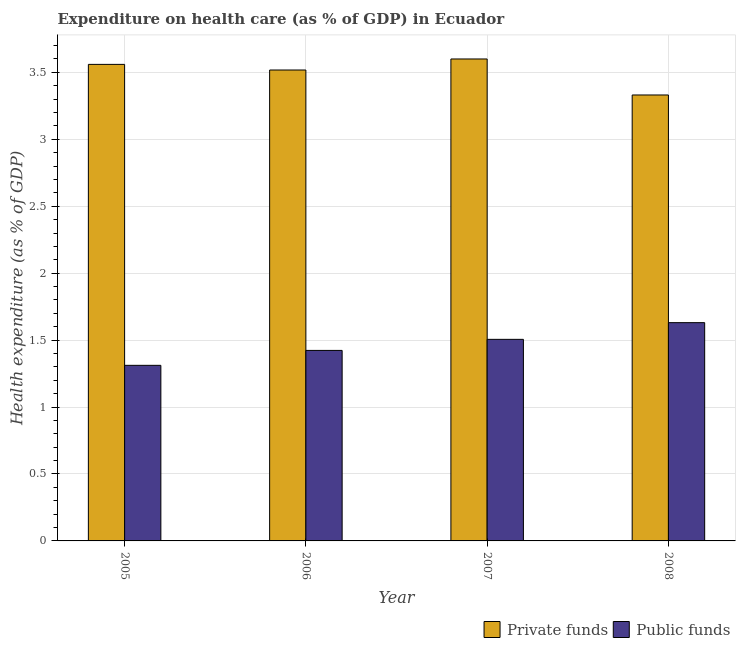How many different coloured bars are there?
Your answer should be compact. 2. How many groups of bars are there?
Keep it short and to the point. 4. Are the number of bars per tick equal to the number of legend labels?
Give a very brief answer. Yes. Are the number of bars on each tick of the X-axis equal?
Offer a very short reply. Yes. What is the label of the 3rd group of bars from the left?
Make the answer very short. 2007. In how many cases, is the number of bars for a given year not equal to the number of legend labels?
Provide a succinct answer. 0. What is the amount of public funds spent in healthcare in 2005?
Keep it short and to the point. 1.31. Across all years, what is the maximum amount of public funds spent in healthcare?
Offer a very short reply. 1.63. Across all years, what is the minimum amount of private funds spent in healthcare?
Give a very brief answer. 3.33. In which year was the amount of private funds spent in healthcare maximum?
Ensure brevity in your answer.  2007. What is the total amount of public funds spent in healthcare in the graph?
Offer a terse response. 5.87. What is the difference between the amount of public funds spent in healthcare in 2006 and that in 2008?
Offer a very short reply. -0.21. What is the difference between the amount of private funds spent in healthcare in 2005 and the amount of public funds spent in healthcare in 2008?
Provide a succinct answer. 0.23. What is the average amount of private funds spent in healthcare per year?
Keep it short and to the point. 3.5. In the year 2006, what is the difference between the amount of private funds spent in healthcare and amount of public funds spent in healthcare?
Make the answer very short. 0. What is the ratio of the amount of private funds spent in healthcare in 2005 to that in 2008?
Your response must be concise. 1.07. Is the amount of public funds spent in healthcare in 2006 less than that in 2007?
Keep it short and to the point. Yes. What is the difference between the highest and the second highest amount of public funds spent in healthcare?
Offer a very short reply. 0.12. What is the difference between the highest and the lowest amount of public funds spent in healthcare?
Your answer should be very brief. 0.32. In how many years, is the amount of public funds spent in healthcare greater than the average amount of public funds spent in healthcare taken over all years?
Provide a succinct answer. 2. What does the 1st bar from the left in 2007 represents?
Keep it short and to the point. Private funds. What does the 1st bar from the right in 2008 represents?
Give a very brief answer. Public funds. How many bars are there?
Offer a terse response. 8. Are all the bars in the graph horizontal?
Make the answer very short. No. Are the values on the major ticks of Y-axis written in scientific E-notation?
Your answer should be very brief. No. Where does the legend appear in the graph?
Your answer should be compact. Bottom right. How are the legend labels stacked?
Your answer should be very brief. Horizontal. What is the title of the graph?
Your answer should be compact. Expenditure on health care (as % of GDP) in Ecuador. What is the label or title of the Y-axis?
Offer a terse response. Health expenditure (as % of GDP). What is the Health expenditure (as % of GDP) in Private funds in 2005?
Offer a very short reply. 3.56. What is the Health expenditure (as % of GDP) of Public funds in 2005?
Keep it short and to the point. 1.31. What is the Health expenditure (as % of GDP) of Private funds in 2006?
Your response must be concise. 3.52. What is the Health expenditure (as % of GDP) in Public funds in 2006?
Make the answer very short. 1.42. What is the Health expenditure (as % of GDP) in Private funds in 2007?
Keep it short and to the point. 3.6. What is the Health expenditure (as % of GDP) of Public funds in 2007?
Your answer should be very brief. 1.51. What is the Health expenditure (as % of GDP) of Private funds in 2008?
Your answer should be compact. 3.33. What is the Health expenditure (as % of GDP) in Public funds in 2008?
Provide a short and direct response. 1.63. Across all years, what is the maximum Health expenditure (as % of GDP) of Private funds?
Your response must be concise. 3.6. Across all years, what is the maximum Health expenditure (as % of GDP) of Public funds?
Your answer should be very brief. 1.63. Across all years, what is the minimum Health expenditure (as % of GDP) in Private funds?
Your answer should be compact. 3.33. Across all years, what is the minimum Health expenditure (as % of GDP) in Public funds?
Your answer should be very brief. 1.31. What is the total Health expenditure (as % of GDP) in Private funds in the graph?
Ensure brevity in your answer.  14.01. What is the total Health expenditure (as % of GDP) of Public funds in the graph?
Make the answer very short. 5.87. What is the difference between the Health expenditure (as % of GDP) of Private funds in 2005 and that in 2006?
Make the answer very short. 0.04. What is the difference between the Health expenditure (as % of GDP) in Public funds in 2005 and that in 2006?
Provide a succinct answer. -0.11. What is the difference between the Health expenditure (as % of GDP) in Private funds in 2005 and that in 2007?
Your response must be concise. -0.04. What is the difference between the Health expenditure (as % of GDP) in Public funds in 2005 and that in 2007?
Your answer should be very brief. -0.19. What is the difference between the Health expenditure (as % of GDP) in Private funds in 2005 and that in 2008?
Your answer should be compact. 0.23. What is the difference between the Health expenditure (as % of GDP) in Public funds in 2005 and that in 2008?
Offer a very short reply. -0.32. What is the difference between the Health expenditure (as % of GDP) of Private funds in 2006 and that in 2007?
Your response must be concise. -0.08. What is the difference between the Health expenditure (as % of GDP) of Public funds in 2006 and that in 2007?
Your response must be concise. -0.08. What is the difference between the Health expenditure (as % of GDP) in Private funds in 2006 and that in 2008?
Your response must be concise. 0.19. What is the difference between the Health expenditure (as % of GDP) of Public funds in 2006 and that in 2008?
Give a very brief answer. -0.21. What is the difference between the Health expenditure (as % of GDP) in Private funds in 2007 and that in 2008?
Your response must be concise. 0.27. What is the difference between the Health expenditure (as % of GDP) in Public funds in 2007 and that in 2008?
Your response must be concise. -0.12. What is the difference between the Health expenditure (as % of GDP) of Private funds in 2005 and the Health expenditure (as % of GDP) of Public funds in 2006?
Keep it short and to the point. 2.14. What is the difference between the Health expenditure (as % of GDP) of Private funds in 2005 and the Health expenditure (as % of GDP) of Public funds in 2007?
Give a very brief answer. 2.05. What is the difference between the Health expenditure (as % of GDP) of Private funds in 2005 and the Health expenditure (as % of GDP) of Public funds in 2008?
Your answer should be compact. 1.93. What is the difference between the Health expenditure (as % of GDP) in Private funds in 2006 and the Health expenditure (as % of GDP) in Public funds in 2007?
Keep it short and to the point. 2.01. What is the difference between the Health expenditure (as % of GDP) in Private funds in 2006 and the Health expenditure (as % of GDP) in Public funds in 2008?
Provide a succinct answer. 1.89. What is the difference between the Health expenditure (as % of GDP) of Private funds in 2007 and the Health expenditure (as % of GDP) of Public funds in 2008?
Your answer should be very brief. 1.97. What is the average Health expenditure (as % of GDP) in Private funds per year?
Make the answer very short. 3.5. What is the average Health expenditure (as % of GDP) of Public funds per year?
Provide a short and direct response. 1.47. In the year 2005, what is the difference between the Health expenditure (as % of GDP) of Private funds and Health expenditure (as % of GDP) of Public funds?
Provide a short and direct response. 2.25. In the year 2006, what is the difference between the Health expenditure (as % of GDP) in Private funds and Health expenditure (as % of GDP) in Public funds?
Provide a short and direct response. 2.09. In the year 2007, what is the difference between the Health expenditure (as % of GDP) of Private funds and Health expenditure (as % of GDP) of Public funds?
Give a very brief answer. 2.09. In the year 2008, what is the difference between the Health expenditure (as % of GDP) of Private funds and Health expenditure (as % of GDP) of Public funds?
Offer a terse response. 1.7. What is the ratio of the Health expenditure (as % of GDP) of Private funds in 2005 to that in 2006?
Provide a short and direct response. 1.01. What is the ratio of the Health expenditure (as % of GDP) of Public funds in 2005 to that in 2006?
Your response must be concise. 0.92. What is the ratio of the Health expenditure (as % of GDP) of Private funds in 2005 to that in 2007?
Your answer should be very brief. 0.99. What is the ratio of the Health expenditure (as % of GDP) in Public funds in 2005 to that in 2007?
Offer a terse response. 0.87. What is the ratio of the Health expenditure (as % of GDP) in Private funds in 2005 to that in 2008?
Provide a short and direct response. 1.07. What is the ratio of the Health expenditure (as % of GDP) in Public funds in 2005 to that in 2008?
Give a very brief answer. 0.8. What is the ratio of the Health expenditure (as % of GDP) in Private funds in 2006 to that in 2007?
Your response must be concise. 0.98. What is the ratio of the Health expenditure (as % of GDP) in Public funds in 2006 to that in 2007?
Ensure brevity in your answer.  0.95. What is the ratio of the Health expenditure (as % of GDP) of Private funds in 2006 to that in 2008?
Provide a short and direct response. 1.06. What is the ratio of the Health expenditure (as % of GDP) in Public funds in 2006 to that in 2008?
Give a very brief answer. 0.87. What is the ratio of the Health expenditure (as % of GDP) of Private funds in 2007 to that in 2008?
Give a very brief answer. 1.08. What is the ratio of the Health expenditure (as % of GDP) in Public funds in 2007 to that in 2008?
Provide a short and direct response. 0.92. What is the difference between the highest and the second highest Health expenditure (as % of GDP) of Private funds?
Your answer should be very brief. 0.04. What is the difference between the highest and the second highest Health expenditure (as % of GDP) in Public funds?
Offer a very short reply. 0.12. What is the difference between the highest and the lowest Health expenditure (as % of GDP) in Private funds?
Ensure brevity in your answer.  0.27. What is the difference between the highest and the lowest Health expenditure (as % of GDP) in Public funds?
Provide a short and direct response. 0.32. 